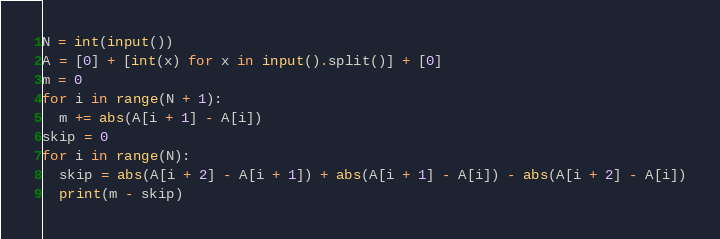<code> <loc_0><loc_0><loc_500><loc_500><_Python_>N = int(input())
A = [0] + [int(x) for x in input().split()] + [0]
m = 0
for i in range(N + 1):
  m += abs(A[i + 1] - A[i])
skip = 0
for i in range(N):
  skip = abs(A[i + 2] - A[i + 1]) + abs(A[i + 1] - A[i]) - abs(A[i + 2] - A[i])
  print(m - skip)</code> 